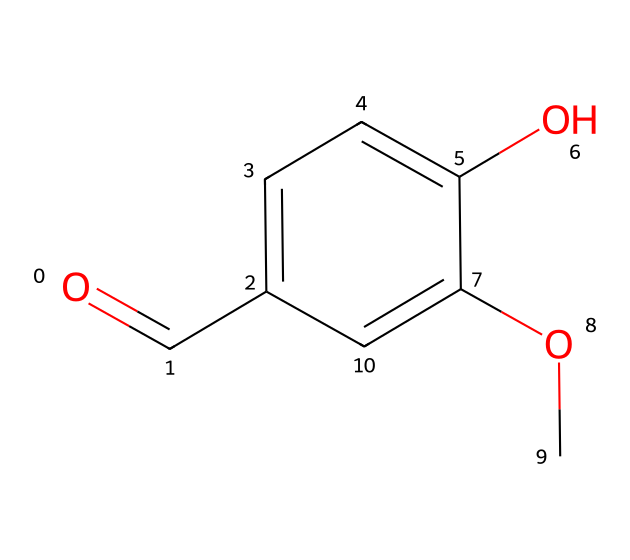What is the main functional group present in this compound? The chemical structure shows a carbonyl group (C=O) indicated by the notation "O=C" at the beginning, which clearly identifies the presence of a carbonyl functional group.
Answer: carbonyl How many carbon atoms are in this molecule? By analyzing the SMILES representation, there are six carbon atoms present in the structure, as indicated by the "c" and "C" symbols.
Answer: 6 What types of bonds are present in this compound? The structure shows various types of bonds, including single bonds (indicated by the symbols connecting the carbon and oxygen atoms) and double bonds (the carbonyl shows a double bond).
Answer: single and double bonds Does this compound contain any aromatic rings? The presence of "c" indicates carbon atoms involved in an aromatic system, and the cyclic structure confirms the presence of an aromatic ring.
Answer: yes What is the total number of hydroxyl (–OH) groups in this molecule? The chemical structure displays one hydroxyl group attached to the aromatic ring, as indicated by "O" which implies a –OH attachment directly on the aromatic carbon.
Answer: 1 What aspects of the molecular structure contribute to the wine's aroma and flavor? The compound shows both hydroxyl and methoxy groups, which are important for the overall aroma and profile of wines. The presence of these functional groups contributes to the modulation of flavors and scents, enhancing the complexity of wine aromas.
Answer: hydroxyl and methoxy groups 